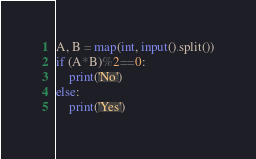<code> <loc_0><loc_0><loc_500><loc_500><_Python_>A, B = map(int, input().split())
if (A*B)%2==0:
	print('No')
else:
	print('Yes')</code> 